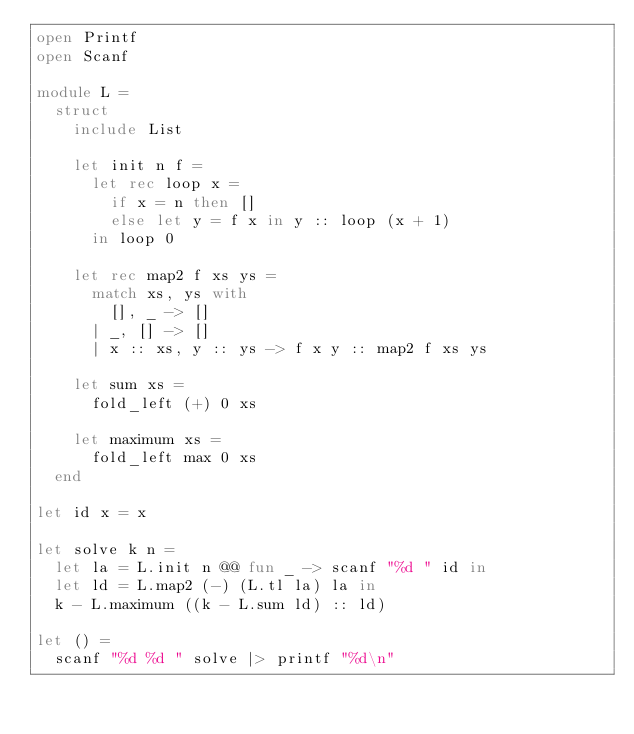Convert code to text. <code><loc_0><loc_0><loc_500><loc_500><_OCaml_>open Printf
open Scanf

module L =
  struct
    include List
  
    let init n f =
      let rec loop x =
        if x = n then []
        else let y = f x in y :: loop (x + 1)
      in loop 0

    let rec map2 f xs ys =
      match xs, ys with
        [], _ -> []
      | _, [] -> []
      | x :: xs, y :: ys -> f x y :: map2 f xs ys

    let sum xs =
      fold_left (+) 0 xs

    let maximum xs =
      fold_left max 0 xs
  end

let id x = x

let solve k n =
  let la = L.init n @@ fun _ -> scanf "%d " id in
  let ld = L.map2 (-) (L.tl la) la in
  k - L.maximum ((k - L.sum ld) :: ld)

let () =
  scanf "%d %d " solve |> printf "%d\n"
</code> 